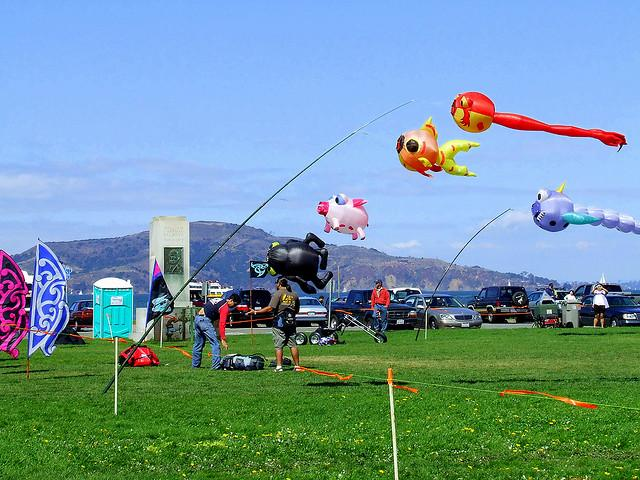Where can you reasonably go to the bathroom here? outhouse 